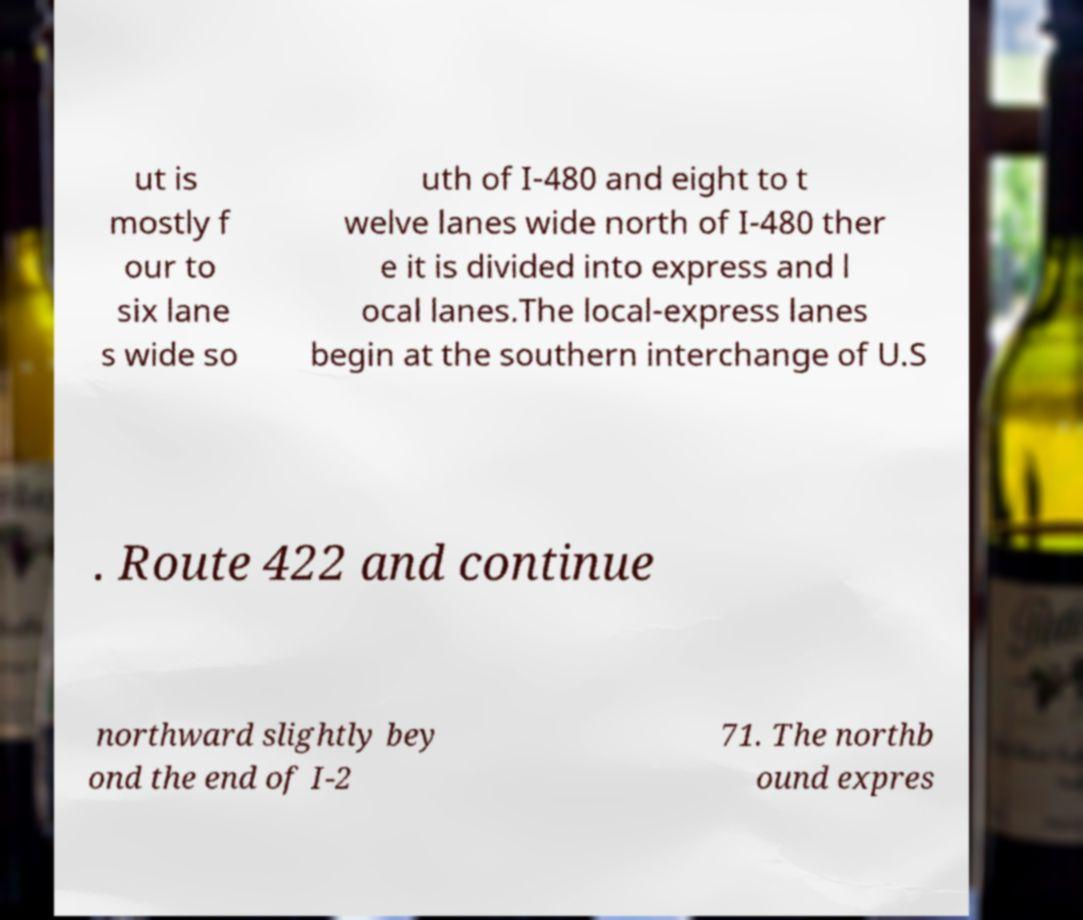Could you extract and type out the text from this image? ut is mostly f our to six lane s wide so uth of I-480 and eight to t welve lanes wide north of I-480 ther e it is divided into express and l ocal lanes.The local-express lanes begin at the southern interchange of U.S . Route 422 and continue northward slightly bey ond the end of I-2 71. The northb ound expres 